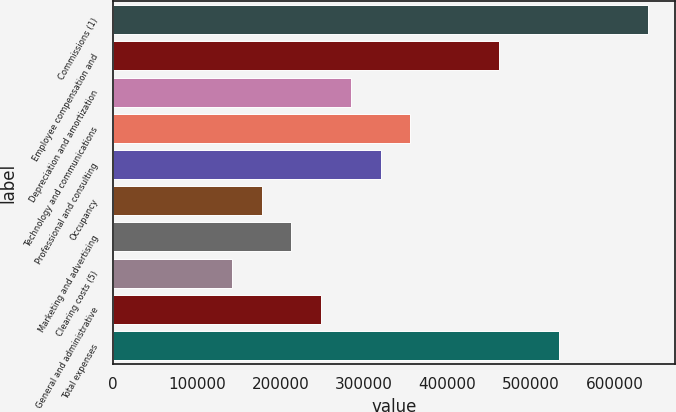<chart> <loc_0><loc_0><loc_500><loc_500><bar_chart><fcel>Commissions (1)<fcel>Employee compensation and<fcel>Depreciation and amortization<fcel>Technology and communications<fcel>Professional and consulting<fcel>Occupancy<fcel>Marketing and advertising<fcel>Clearing costs (5)<fcel>General and administrative<fcel>Total expenses<nl><fcel>639507<fcel>461866<fcel>284226<fcel>355282<fcel>319754<fcel>177642<fcel>213170<fcel>142114<fcel>248698<fcel>532922<nl></chart> 